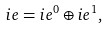Convert formula to latex. <formula><loc_0><loc_0><loc_500><loc_500>\sl i e = \sl i e ^ { 0 } \oplus \sl i e ^ { 1 } ,</formula> 